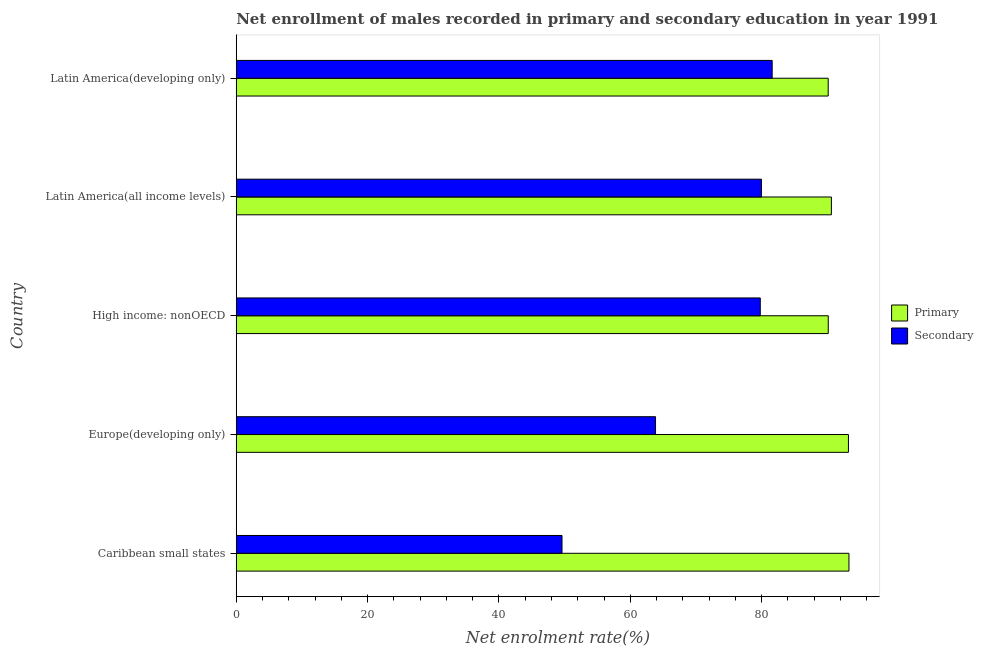How many different coloured bars are there?
Keep it short and to the point. 2. How many groups of bars are there?
Offer a terse response. 5. Are the number of bars on each tick of the Y-axis equal?
Make the answer very short. Yes. What is the label of the 2nd group of bars from the top?
Give a very brief answer. Latin America(all income levels). What is the enrollment rate in secondary education in High income: nonOECD?
Offer a terse response. 79.8. Across all countries, what is the maximum enrollment rate in secondary education?
Make the answer very short. 81.61. Across all countries, what is the minimum enrollment rate in secondary education?
Your response must be concise. 49.61. In which country was the enrollment rate in secondary education maximum?
Provide a succinct answer. Latin America(developing only). In which country was the enrollment rate in secondary education minimum?
Make the answer very short. Caribbean small states. What is the total enrollment rate in secondary education in the graph?
Keep it short and to the point. 354.84. What is the difference between the enrollment rate in secondary education in Europe(developing only) and that in Latin America(developing only)?
Offer a terse response. -17.76. What is the difference between the enrollment rate in primary education in Europe(developing only) and the enrollment rate in secondary education in Latin America(all income levels)?
Keep it short and to the point. 13.25. What is the average enrollment rate in secondary education per country?
Make the answer very short. 70.97. What is the difference between the enrollment rate in primary education and enrollment rate in secondary education in Latin America(all income levels)?
Your answer should be very brief. 10.65. In how many countries, is the enrollment rate in secondary education greater than 56 %?
Offer a very short reply. 4. What is the ratio of the enrollment rate in secondary education in Caribbean small states to that in Latin America(developing only)?
Your answer should be very brief. 0.61. Is the enrollment rate in primary education in High income: nonOECD less than that in Latin America(all income levels)?
Your answer should be compact. Yes. Is the difference between the enrollment rate in primary education in Europe(developing only) and Latin America(all income levels) greater than the difference between the enrollment rate in secondary education in Europe(developing only) and Latin America(all income levels)?
Provide a succinct answer. Yes. What is the difference between the highest and the second highest enrollment rate in secondary education?
Give a very brief answer. 1.63. What is the difference between the highest and the lowest enrollment rate in primary education?
Offer a terse response. 3.16. Is the sum of the enrollment rate in secondary education in Caribbean small states and Europe(developing only) greater than the maximum enrollment rate in primary education across all countries?
Make the answer very short. Yes. What does the 2nd bar from the top in Latin America(developing only) represents?
Provide a succinct answer. Primary. What does the 2nd bar from the bottom in Caribbean small states represents?
Make the answer very short. Secondary. How many bars are there?
Ensure brevity in your answer.  10. Are all the bars in the graph horizontal?
Your answer should be compact. Yes. What is the difference between two consecutive major ticks on the X-axis?
Offer a very short reply. 20. Does the graph contain any zero values?
Offer a very short reply. No. Does the graph contain grids?
Keep it short and to the point. No. How many legend labels are there?
Keep it short and to the point. 2. What is the title of the graph?
Your response must be concise. Net enrollment of males recorded in primary and secondary education in year 1991. Does "Borrowers" appear as one of the legend labels in the graph?
Make the answer very short. No. What is the label or title of the X-axis?
Offer a very short reply. Net enrolment rate(%). What is the Net enrolment rate(%) of Primary in Caribbean small states?
Provide a short and direct response. 93.3. What is the Net enrolment rate(%) in Secondary in Caribbean small states?
Provide a short and direct response. 49.61. What is the Net enrolment rate(%) in Primary in Europe(developing only)?
Keep it short and to the point. 93.23. What is the Net enrolment rate(%) in Secondary in Europe(developing only)?
Ensure brevity in your answer.  63.85. What is the Net enrolment rate(%) of Primary in High income: nonOECD?
Provide a succinct answer. 90.15. What is the Net enrolment rate(%) of Secondary in High income: nonOECD?
Provide a short and direct response. 79.8. What is the Net enrolment rate(%) of Primary in Latin America(all income levels)?
Your answer should be compact. 90.63. What is the Net enrolment rate(%) in Secondary in Latin America(all income levels)?
Provide a short and direct response. 79.98. What is the Net enrolment rate(%) of Primary in Latin America(developing only)?
Your response must be concise. 90.14. What is the Net enrolment rate(%) in Secondary in Latin America(developing only)?
Offer a terse response. 81.61. Across all countries, what is the maximum Net enrolment rate(%) in Primary?
Offer a very short reply. 93.3. Across all countries, what is the maximum Net enrolment rate(%) in Secondary?
Your response must be concise. 81.61. Across all countries, what is the minimum Net enrolment rate(%) of Primary?
Provide a succinct answer. 90.14. Across all countries, what is the minimum Net enrolment rate(%) in Secondary?
Your answer should be compact. 49.61. What is the total Net enrolment rate(%) of Primary in the graph?
Make the answer very short. 457.45. What is the total Net enrolment rate(%) of Secondary in the graph?
Provide a short and direct response. 354.84. What is the difference between the Net enrolment rate(%) in Primary in Caribbean small states and that in Europe(developing only)?
Your answer should be compact. 0.08. What is the difference between the Net enrolment rate(%) of Secondary in Caribbean small states and that in Europe(developing only)?
Keep it short and to the point. -14.24. What is the difference between the Net enrolment rate(%) in Primary in Caribbean small states and that in High income: nonOECD?
Ensure brevity in your answer.  3.15. What is the difference between the Net enrolment rate(%) in Secondary in Caribbean small states and that in High income: nonOECD?
Make the answer very short. -30.19. What is the difference between the Net enrolment rate(%) in Primary in Caribbean small states and that in Latin America(all income levels)?
Your answer should be compact. 2.67. What is the difference between the Net enrolment rate(%) of Secondary in Caribbean small states and that in Latin America(all income levels)?
Ensure brevity in your answer.  -30.37. What is the difference between the Net enrolment rate(%) in Primary in Caribbean small states and that in Latin America(developing only)?
Provide a short and direct response. 3.16. What is the difference between the Net enrolment rate(%) of Secondary in Caribbean small states and that in Latin America(developing only)?
Your answer should be compact. -32. What is the difference between the Net enrolment rate(%) of Primary in Europe(developing only) and that in High income: nonOECD?
Provide a short and direct response. 3.07. What is the difference between the Net enrolment rate(%) in Secondary in Europe(developing only) and that in High income: nonOECD?
Keep it short and to the point. -15.95. What is the difference between the Net enrolment rate(%) of Primary in Europe(developing only) and that in Latin America(all income levels)?
Keep it short and to the point. 2.6. What is the difference between the Net enrolment rate(%) of Secondary in Europe(developing only) and that in Latin America(all income levels)?
Offer a very short reply. -16.13. What is the difference between the Net enrolment rate(%) of Primary in Europe(developing only) and that in Latin America(developing only)?
Provide a short and direct response. 3.08. What is the difference between the Net enrolment rate(%) of Secondary in Europe(developing only) and that in Latin America(developing only)?
Provide a succinct answer. -17.76. What is the difference between the Net enrolment rate(%) in Primary in High income: nonOECD and that in Latin America(all income levels)?
Make the answer very short. -0.48. What is the difference between the Net enrolment rate(%) of Secondary in High income: nonOECD and that in Latin America(all income levels)?
Offer a terse response. -0.18. What is the difference between the Net enrolment rate(%) in Primary in High income: nonOECD and that in Latin America(developing only)?
Your response must be concise. 0.01. What is the difference between the Net enrolment rate(%) of Secondary in High income: nonOECD and that in Latin America(developing only)?
Your response must be concise. -1.81. What is the difference between the Net enrolment rate(%) in Primary in Latin America(all income levels) and that in Latin America(developing only)?
Provide a succinct answer. 0.49. What is the difference between the Net enrolment rate(%) of Secondary in Latin America(all income levels) and that in Latin America(developing only)?
Provide a short and direct response. -1.63. What is the difference between the Net enrolment rate(%) in Primary in Caribbean small states and the Net enrolment rate(%) in Secondary in Europe(developing only)?
Keep it short and to the point. 29.45. What is the difference between the Net enrolment rate(%) of Primary in Caribbean small states and the Net enrolment rate(%) of Secondary in High income: nonOECD?
Your response must be concise. 13.5. What is the difference between the Net enrolment rate(%) of Primary in Caribbean small states and the Net enrolment rate(%) of Secondary in Latin America(all income levels)?
Keep it short and to the point. 13.33. What is the difference between the Net enrolment rate(%) of Primary in Caribbean small states and the Net enrolment rate(%) of Secondary in Latin America(developing only)?
Offer a very short reply. 11.69. What is the difference between the Net enrolment rate(%) in Primary in Europe(developing only) and the Net enrolment rate(%) in Secondary in High income: nonOECD?
Provide a short and direct response. 13.42. What is the difference between the Net enrolment rate(%) in Primary in Europe(developing only) and the Net enrolment rate(%) in Secondary in Latin America(all income levels)?
Give a very brief answer. 13.25. What is the difference between the Net enrolment rate(%) in Primary in Europe(developing only) and the Net enrolment rate(%) in Secondary in Latin America(developing only)?
Make the answer very short. 11.61. What is the difference between the Net enrolment rate(%) of Primary in High income: nonOECD and the Net enrolment rate(%) of Secondary in Latin America(all income levels)?
Your answer should be compact. 10.18. What is the difference between the Net enrolment rate(%) of Primary in High income: nonOECD and the Net enrolment rate(%) of Secondary in Latin America(developing only)?
Provide a short and direct response. 8.54. What is the difference between the Net enrolment rate(%) of Primary in Latin America(all income levels) and the Net enrolment rate(%) of Secondary in Latin America(developing only)?
Your answer should be compact. 9.02. What is the average Net enrolment rate(%) in Primary per country?
Your answer should be compact. 91.49. What is the average Net enrolment rate(%) in Secondary per country?
Your response must be concise. 70.97. What is the difference between the Net enrolment rate(%) in Primary and Net enrolment rate(%) in Secondary in Caribbean small states?
Give a very brief answer. 43.7. What is the difference between the Net enrolment rate(%) in Primary and Net enrolment rate(%) in Secondary in Europe(developing only)?
Provide a succinct answer. 29.38. What is the difference between the Net enrolment rate(%) of Primary and Net enrolment rate(%) of Secondary in High income: nonOECD?
Your answer should be very brief. 10.35. What is the difference between the Net enrolment rate(%) of Primary and Net enrolment rate(%) of Secondary in Latin America(all income levels)?
Ensure brevity in your answer.  10.65. What is the difference between the Net enrolment rate(%) of Primary and Net enrolment rate(%) of Secondary in Latin America(developing only)?
Your answer should be very brief. 8.53. What is the ratio of the Net enrolment rate(%) in Primary in Caribbean small states to that in Europe(developing only)?
Provide a short and direct response. 1. What is the ratio of the Net enrolment rate(%) of Secondary in Caribbean small states to that in Europe(developing only)?
Give a very brief answer. 0.78. What is the ratio of the Net enrolment rate(%) in Primary in Caribbean small states to that in High income: nonOECD?
Keep it short and to the point. 1.03. What is the ratio of the Net enrolment rate(%) in Secondary in Caribbean small states to that in High income: nonOECD?
Your response must be concise. 0.62. What is the ratio of the Net enrolment rate(%) of Primary in Caribbean small states to that in Latin America(all income levels)?
Your response must be concise. 1.03. What is the ratio of the Net enrolment rate(%) of Secondary in Caribbean small states to that in Latin America(all income levels)?
Offer a terse response. 0.62. What is the ratio of the Net enrolment rate(%) in Primary in Caribbean small states to that in Latin America(developing only)?
Give a very brief answer. 1.04. What is the ratio of the Net enrolment rate(%) of Secondary in Caribbean small states to that in Latin America(developing only)?
Ensure brevity in your answer.  0.61. What is the ratio of the Net enrolment rate(%) of Primary in Europe(developing only) to that in High income: nonOECD?
Your answer should be compact. 1.03. What is the ratio of the Net enrolment rate(%) of Secondary in Europe(developing only) to that in High income: nonOECD?
Offer a very short reply. 0.8. What is the ratio of the Net enrolment rate(%) of Primary in Europe(developing only) to that in Latin America(all income levels)?
Give a very brief answer. 1.03. What is the ratio of the Net enrolment rate(%) of Secondary in Europe(developing only) to that in Latin America(all income levels)?
Provide a succinct answer. 0.8. What is the ratio of the Net enrolment rate(%) in Primary in Europe(developing only) to that in Latin America(developing only)?
Offer a terse response. 1.03. What is the ratio of the Net enrolment rate(%) of Secondary in Europe(developing only) to that in Latin America(developing only)?
Offer a very short reply. 0.78. What is the ratio of the Net enrolment rate(%) of Secondary in High income: nonOECD to that in Latin America(developing only)?
Make the answer very short. 0.98. What is the ratio of the Net enrolment rate(%) of Primary in Latin America(all income levels) to that in Latin America(developing only)?
Provide a short and direct response. 1.01. What is the difference between the highest and the second highest Net enrolment rate(%) in Primary?
Make the answer very short. 0.08. What is the difference between the highest and the second highest Net enrolment rate(%) of Secondary?
Keep it short and to the point. 1.63. What is the difference between the highest and the lowest Net enrolment rate(%) in Primary?
Offer a terse response. 3.16. What is the difference between the highest and the lowest Net enrolment rate(%) in Secondary?
Your response must be concise. 32. 